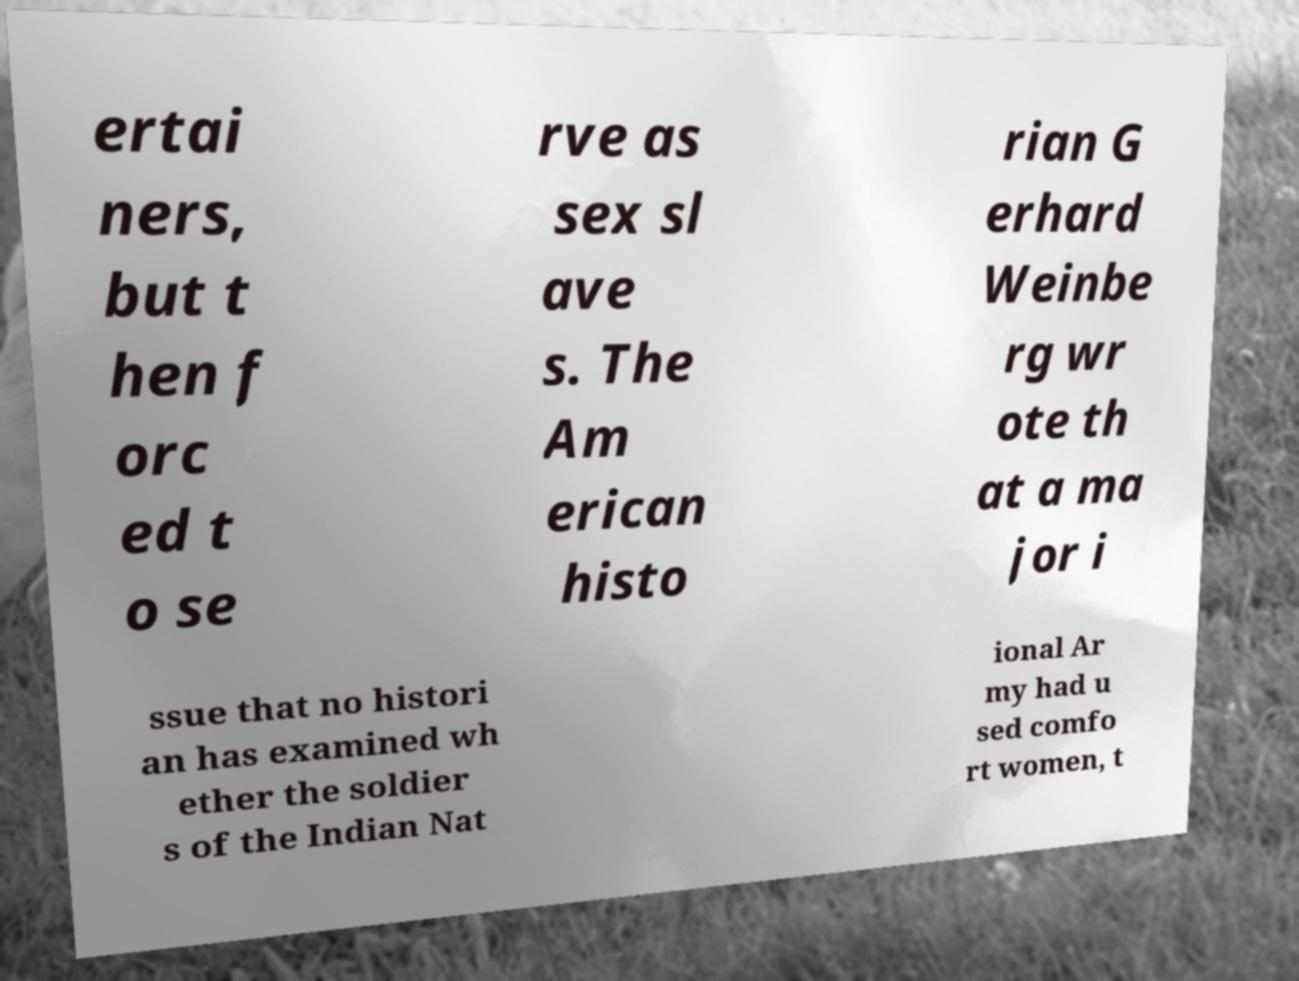I need the written content from this picture converted into text. Can you do that? ertai ners, but t hen f orc ed t o se rve as sex sl ave s. The Am erican histo rian G erhard Weinbe rg wr ote th at a ma jor i ssue that no histori an has examined wh ether the soldier s of the Indian Nat ional Ar my had u sed comfo rt women, t 